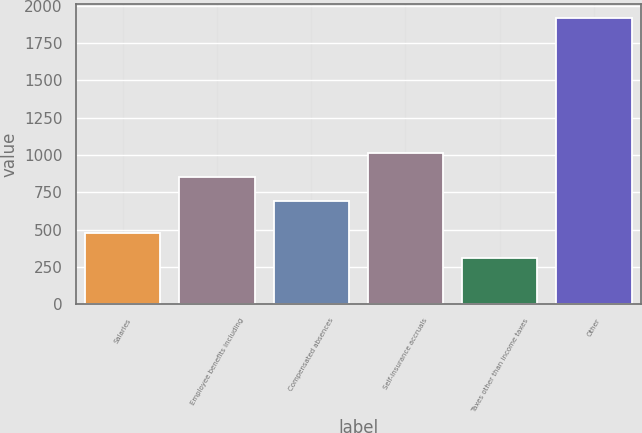<chart> <loc_0><loc_0><loc_500><loc_500><bar_chart><fcel>Salaries<fcel>Employee benefits including<fcel>Compensated absences<fcel>Self-insurance accruals<fcel>Taxes other than income taxes<fcel>Other<nl><fcel>478<fcel>850.4<fcel>690<fcel>1010.8<fcel>311<fcel>1915<nl></chart> 